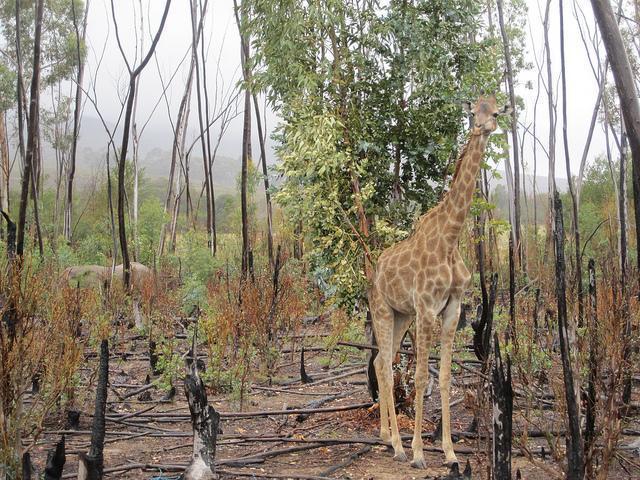How many giraffes are there?
Give a very brief answer. 1. How many giraffes can be seen?
Give a very brief answer. 1. How many people have been partially caught by the camera?
Give a very brief answer. 0. 